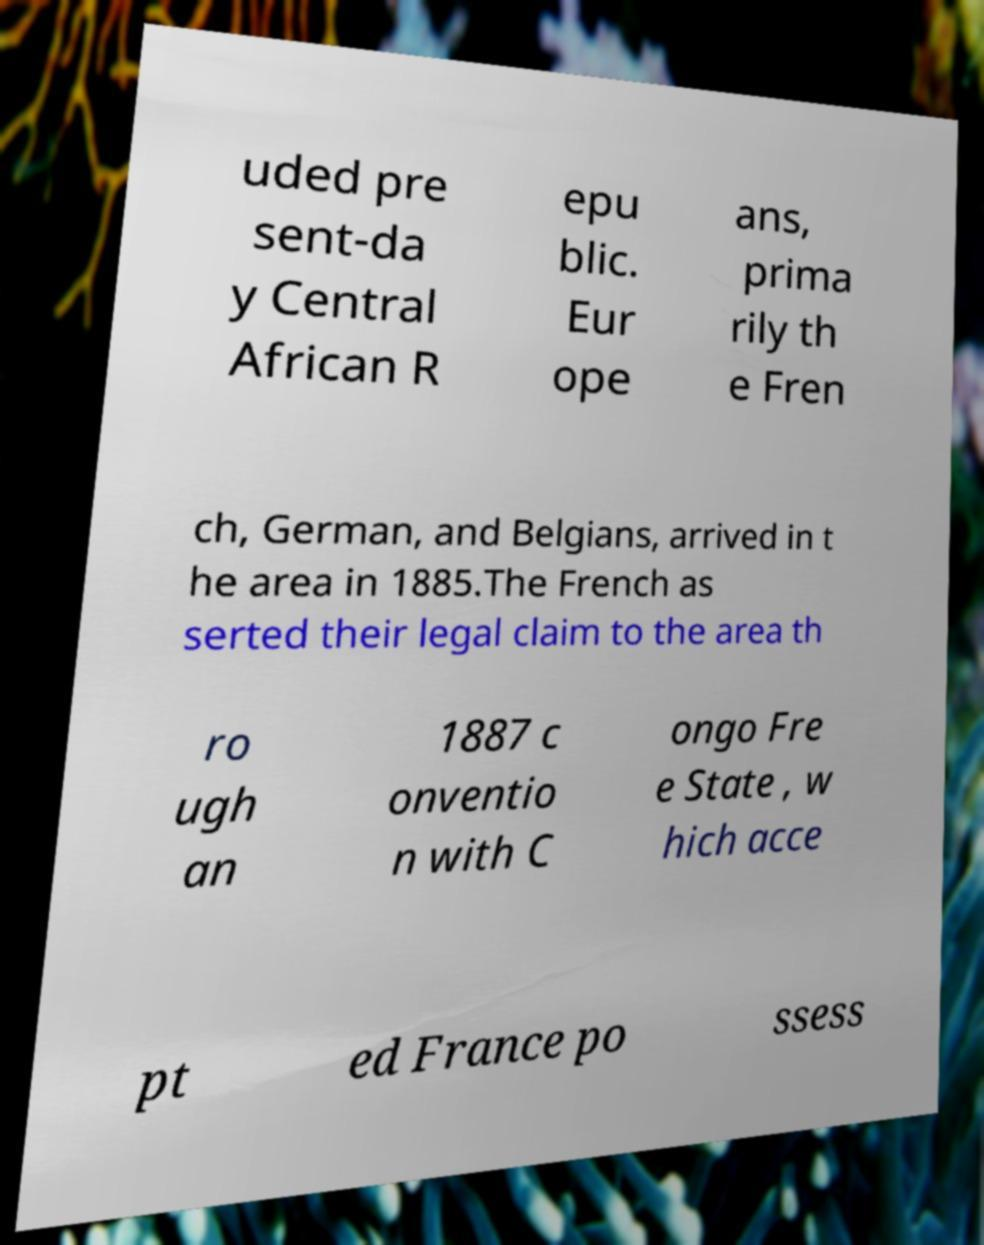Can you read and provide the text displayed in the image?This photo seems to have some interesting text. Can you extract and type it out for me? uded pre sent-da y Central African R epu blic. Eur ope ans, prima rily th e Fren ch, German, and Belgians, arrived in t he area in 1885.The French as serted their legal claim to the area th ro ugh an 1887 c onventio n with C ongo Fre e State , w hich acce pt ed France po ssess 